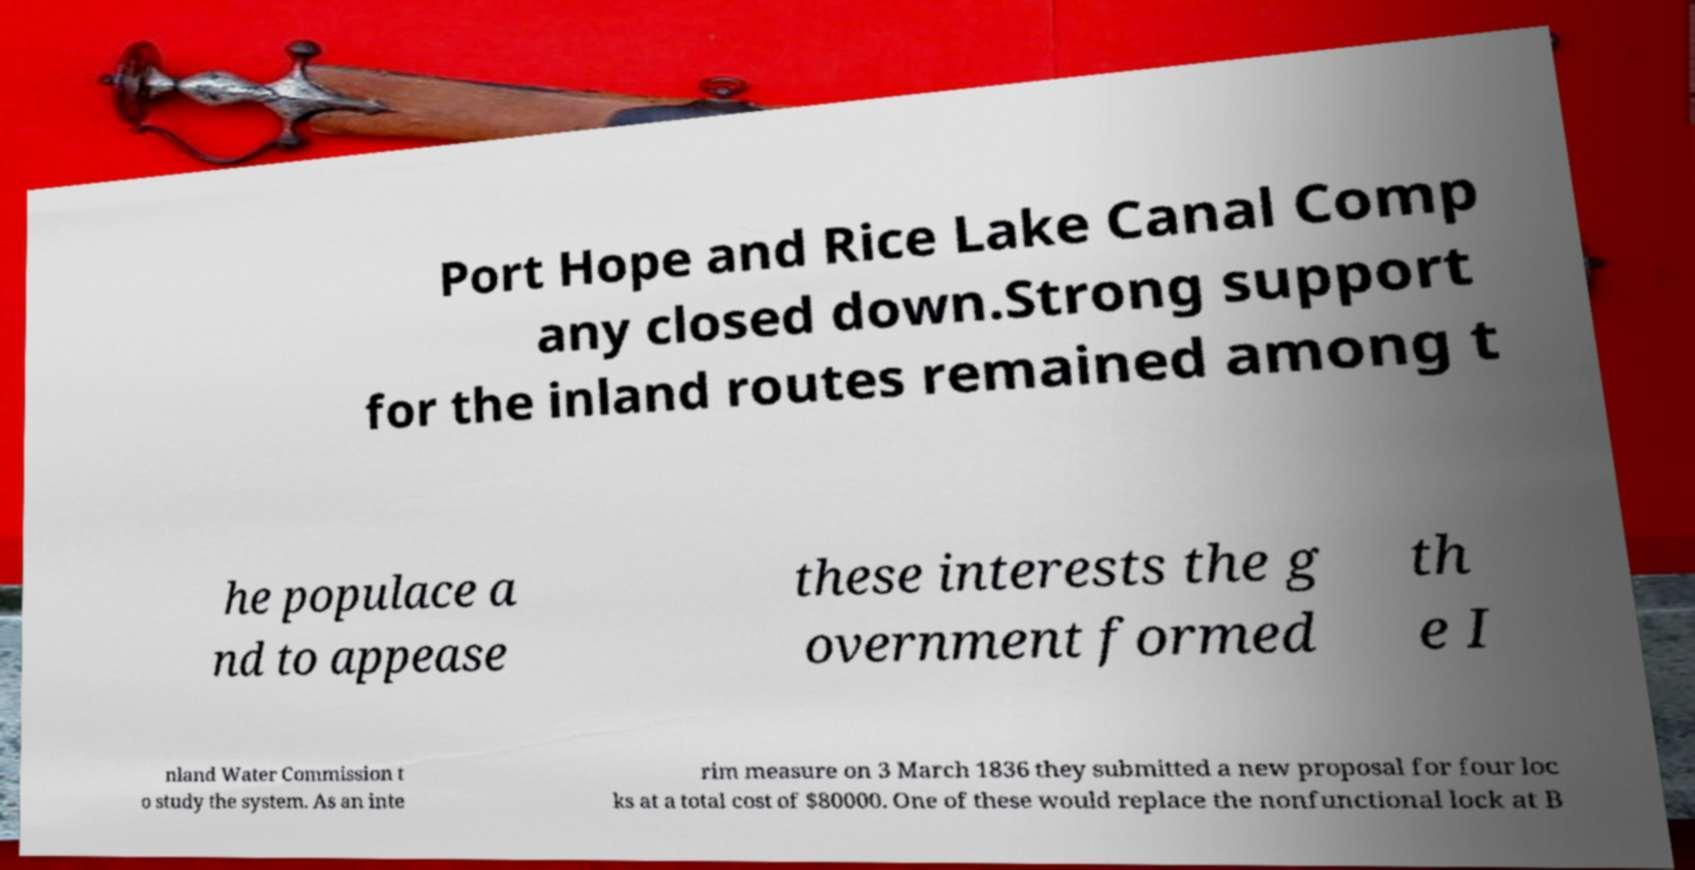Could you assist in decoding the text presented in this image and type it out clearly? Port Hope and Rice Lake Canal Comp any closed down.Strong support for the inland routes remained among t he populace a nd to appease these interests the g overnment formed th e I nland Water Commission t o study the system. As an inte rim measure on 3 March 1836 they submitted a new proposal for four loc ks at a total cost of $80000. One of these would replace the nonfunctional lock at B 